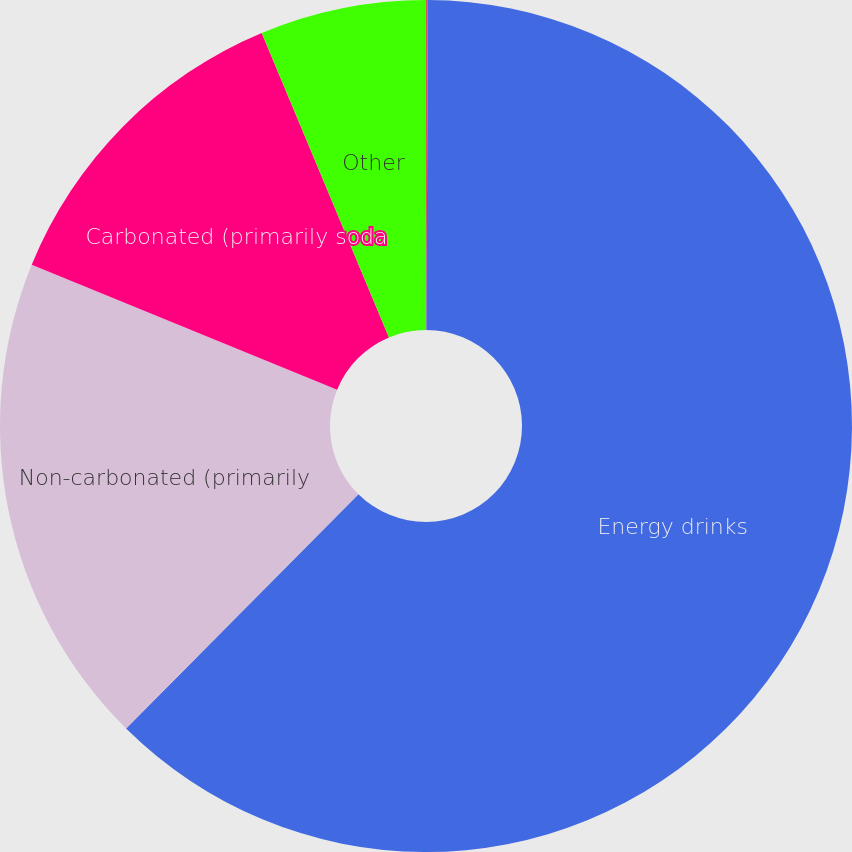<chart> <loc_0><loc_0><loc_500><loc_500><pie_chart><fcel>Product Line<fcel>Energy drinks<fcel>Non-carbonated (primarily<fcel>Carbonated (primarily soda<fcel>Other<nl><fcel>0.07%<fcel>62.36%<fcel>18.75%<fcel>12.52%<fcel>6.3%<nl></chart> 